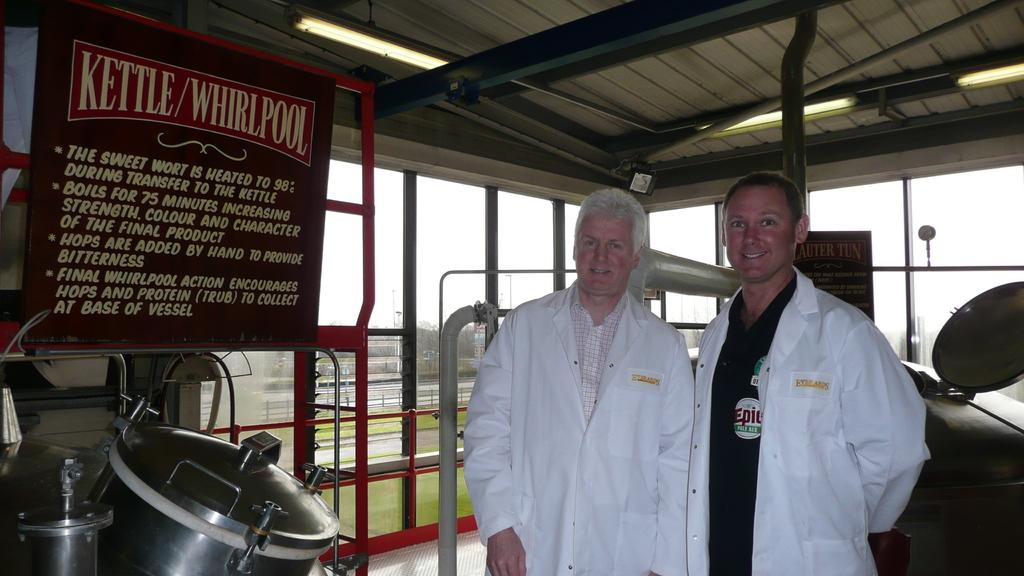<image>
Provide a brief description of the given image. Two men in white lab coats are standing next to a kettle in a brewery. 